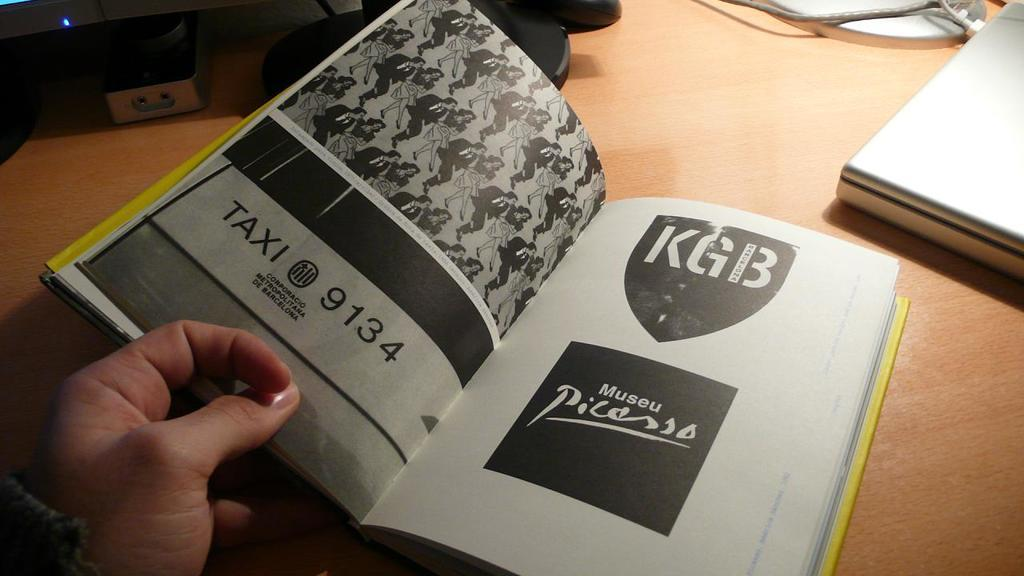<image>
Describe the image concisely. A guide book has Museu Picaso written inside 